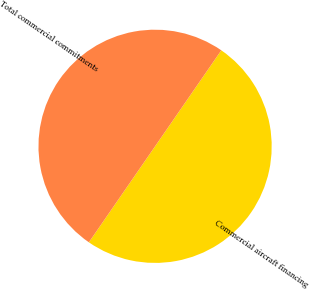Convert chart to OTSL. <chart><loc_0><loc_0><loc_500><loc_500><pie_chart><fcel>Commercial aircraft financing<fcel>Total commercial commitments<nl><fcel>50.0%<fcel>50.0%<nl></chart> 